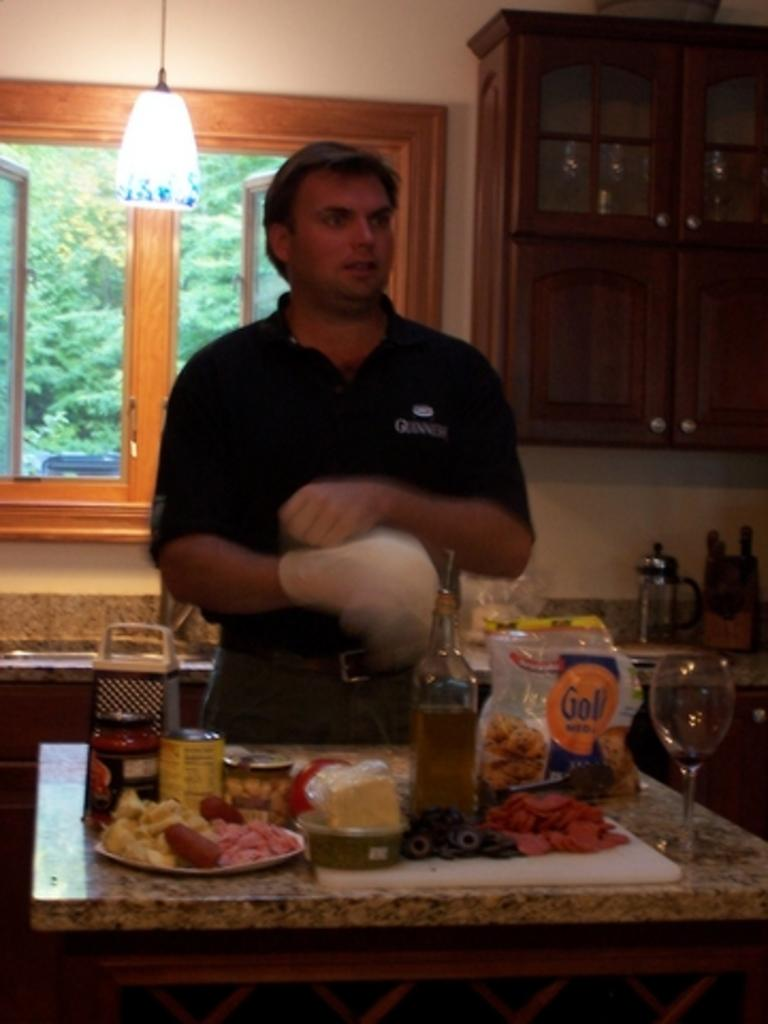Who is present in the image? There is a man in the image. What is in front of the man? There is a table in front of the man. What can be seen on the table? There are objects on the table. What can be seen in the background of the image? There is a wall, a cabinet, a light, and a window in the background of the image. What type of current is flowing through the cellar in the image? There is no cellar present in the image, and therefore no current can be observed. 